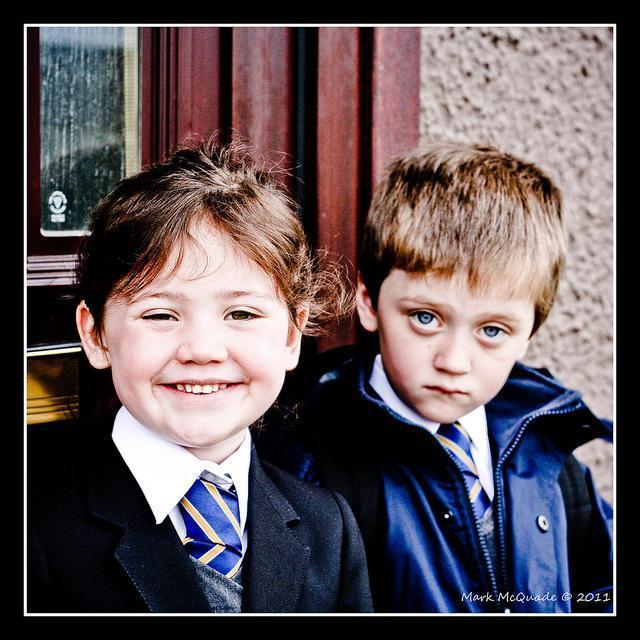How many children are there?
Give a very brief answer. 2. How many people are there?
Give a very brief answer. 2. 